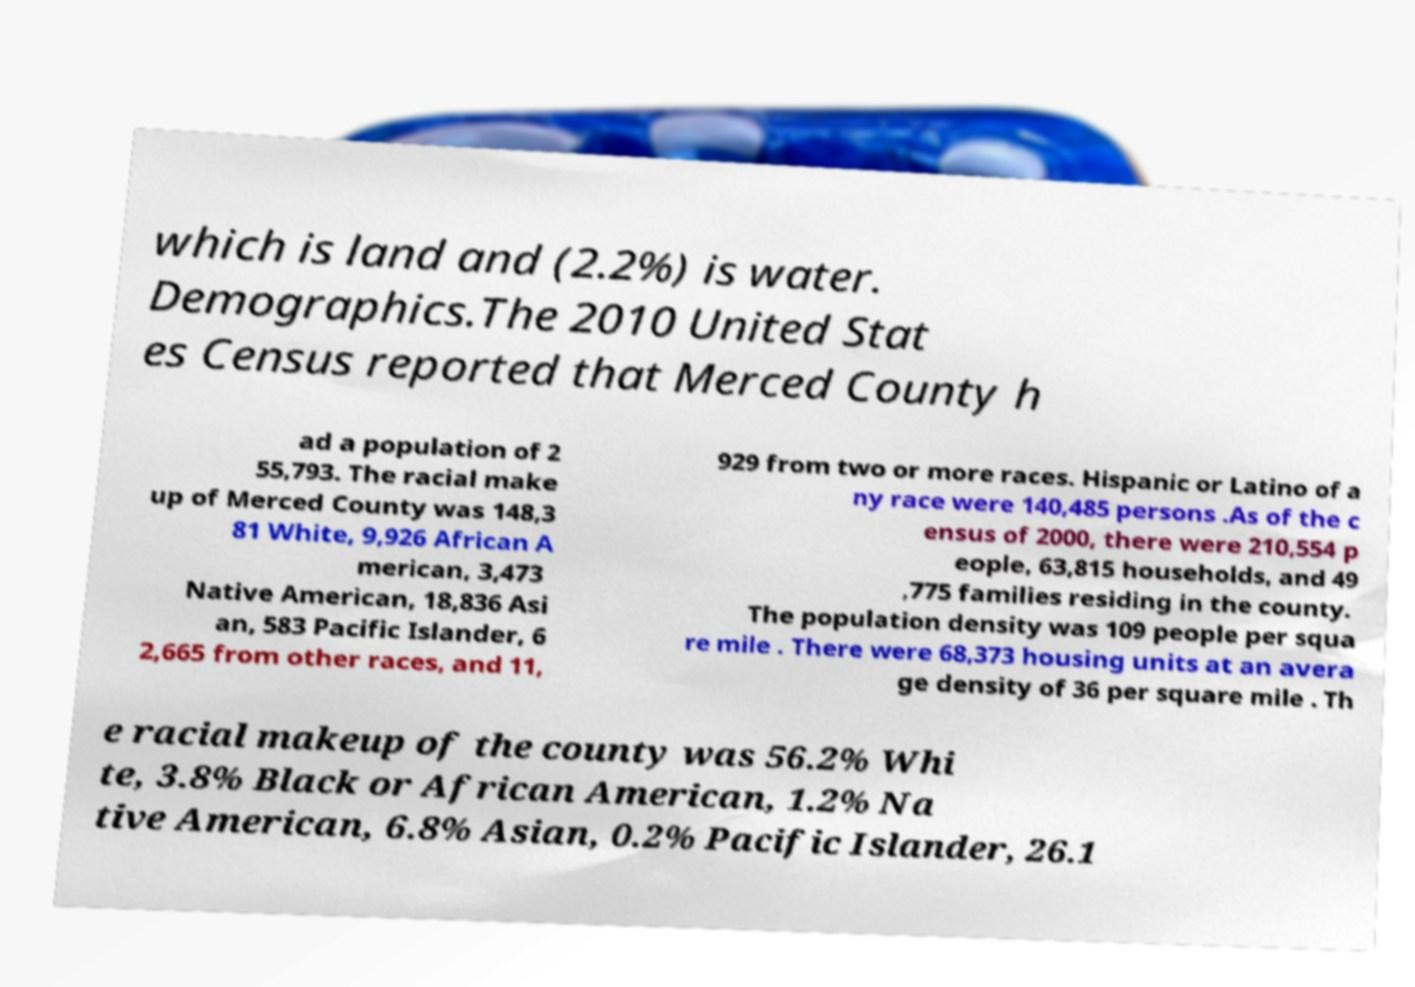There's text embedded in this image that I need extracted. Can you transcribe it verbatim? which is land and (2.2%) is water. Demographics.The 2010 United Stat es Census reported that Merced County h ad a population of 2 55,793. The racial make up of Merced County was 148,3 81 White, 9,926 African A merican, 3,473 Native American, 18,836 Asi an, 583 Pacific Islander, 6 2,665 from other races, and 11, 929 from two or more races. Hispanic or Latino of a ny race were 140,485 persons .As of the c ensus of 2000, there were 210,554 p eople, 63,815 households, and 49 ,775 families residing in the county. The population density was 109 people per squa re mile . There were 68,373 housing units at an avera ge density of 36 per square mile . Th e racial makeup of the county was 56.2% Whi te, 3.8% Black or African American, 1.2% Na tive American, 6.8% Asian, 0.2% Pacific Islander, 26.1 